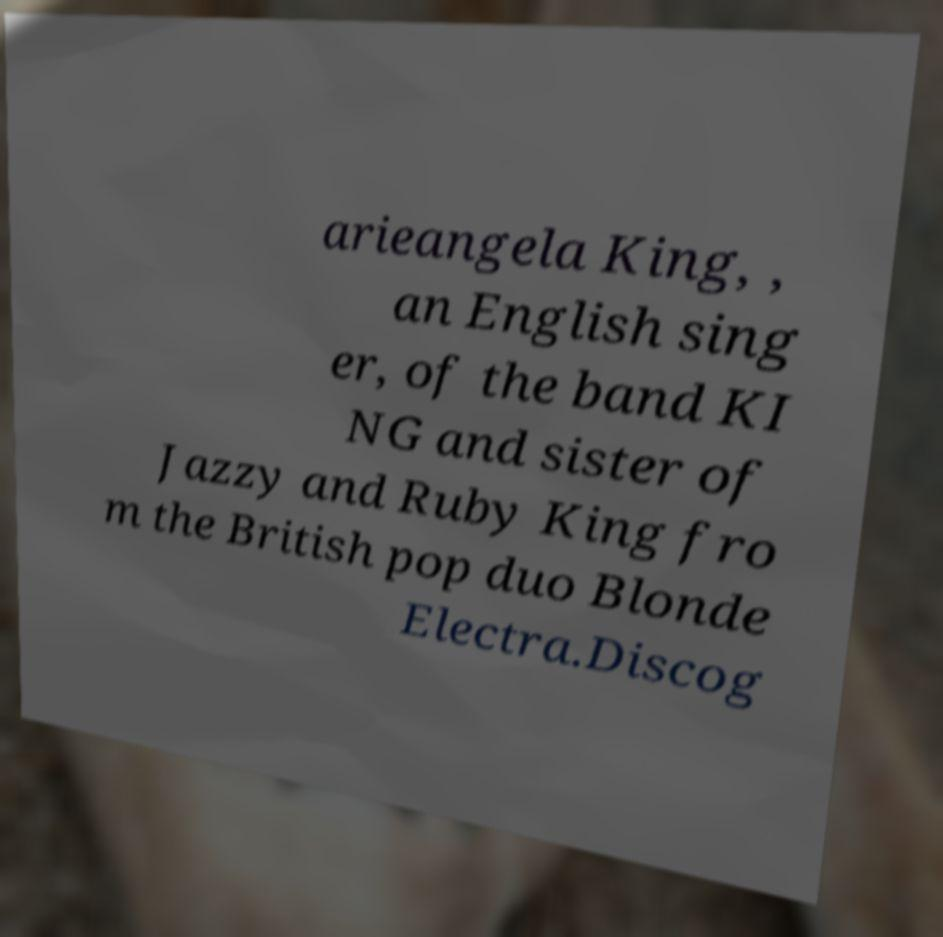I need the written content from this picture converted into text. Can you do that? arieangela King, , an English sing er, of the band KI NG and sister of Jazzy and Ruby King fro m the British pop duo Blonde Electra.Discog 